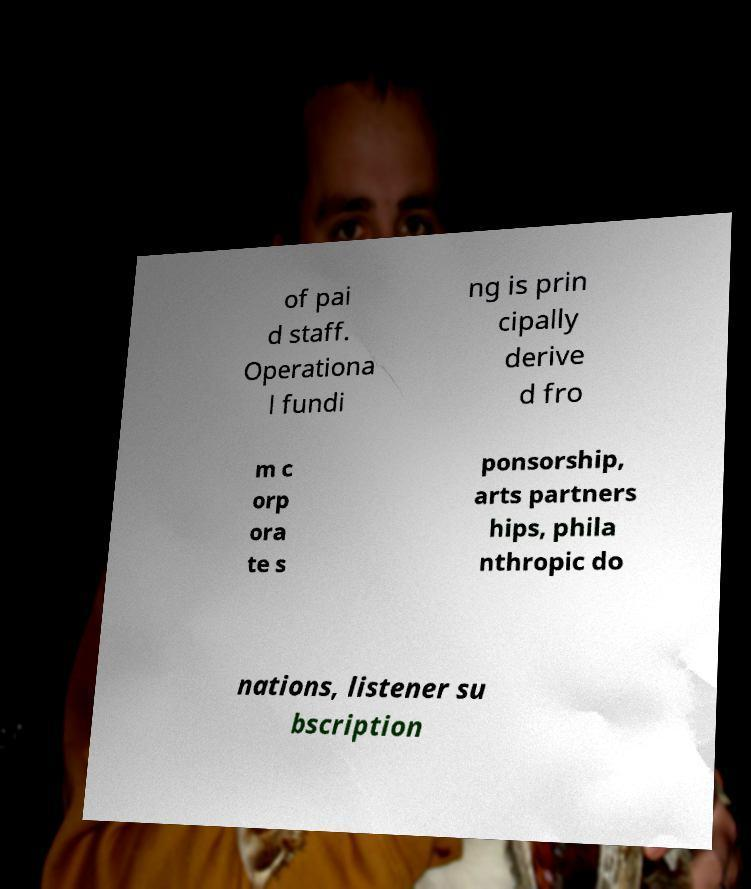For documentation purposes, I need the text within this image transcribed. Could you provide that? of pai d staff. Operationa l fundi ng is prin cipally derive d fro m c orp ora te s ponsorship, arts partners hips, phila nthropic do nations, listener su bscription 